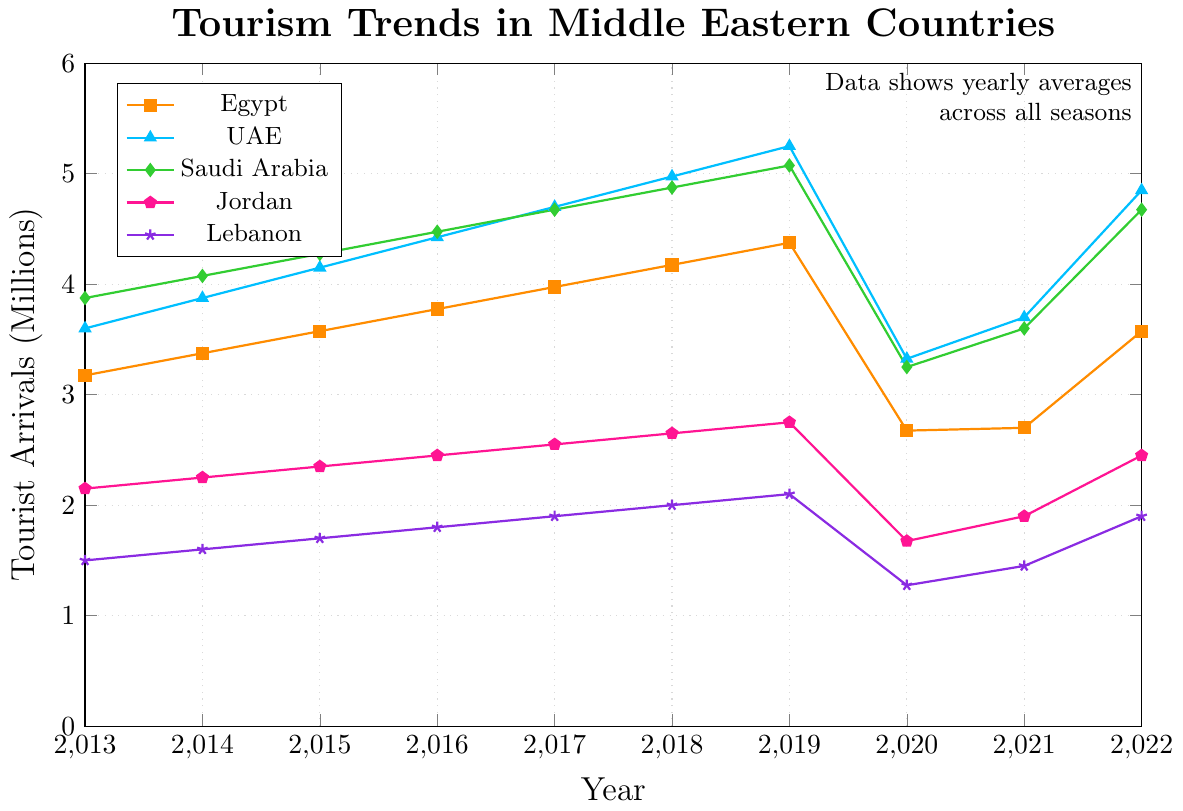Which country experienced the largest drop in tourist arrivals from 2019 to 2020? To determine which country experienced the largest drop, subtract the 2020 average from the 2019 average for each country and compare the differences. The drops are: Egypt (4.375 - 2.675 = 1.700), UAE (5.250 - 3.325 = 1.925), Saudi Arabia (5.075 - 3.250 = 1.825), Jordan (2.750 - 1.675 = 1.075), Lebanon (2.100 - 1.275 = 0.825). The largest drop occurred in the UAE.
Answer: UAE Which country had the highest average tourist arrivals over the entire decade? Sum the yearly averages for each country and divide by the number of years (10) to find the average. The calculations are: Egypt (37.5/10 = 3.75), UAE (45.25/10 = 4.525), Saudi Arabia (43.75/10 = 4.375), Jordan (23.25/10 = 2.325), Lebanon (16.75/10 = 1.675). The highest average is for the UAE.
Answer: UAE How did tourist arrivals in Lebanon compare to those in Jordan in 2020? Compare the average tourist arrivals between Lebanon and Jordan for 2020: Lebanon (1.275), Jordan (1.675). Jordan had more tourist arrivals than Lebanon in 2020.
Answer: Jordan had more In which year did Egypt see the highest average tourist arrivals? To identify Egypt’s highest average tourist arrivals, scan the plotted data points for Egypt. The highest point is in 2019 with an average of 4.375 million.
Answer: 2019 Did Saudi Arabia's average tourist arrivals increase or decrease from 2013 to 2022? Compare the average values for Saudi Arabia in 2013 (3.875) and 2022 (4.675). The average increased over the time period.
Answer: Increase Which year shows the highest average tourist arrivals across all five countries? Calculate the average for all five countries for each year, then identify the highest value. For instance, 2019's averages sum is (4.375 + 5.250 + 5.075 + 2.750 + 2.100) = 19.55/5 = 3.91. Repeat this for all years; 2019 has the highest average.
Answer: 2019 What is the average difference in tourist arrivals between summer and fall for Saudi Arabia? The difference between summer and fall for each year is (2013: -1.1, 2014: -1.1, 2015: -1.1, 2016: -1.1, 2017: -1.1, 2018: -1.1, 2019: -1.1, 2020: -1.1, 2021: -1.1, 2022: -1.1). Such a consistent pattern can easily be averaged as (-1.1)/1 = -1.1.
Answer: -1.1 